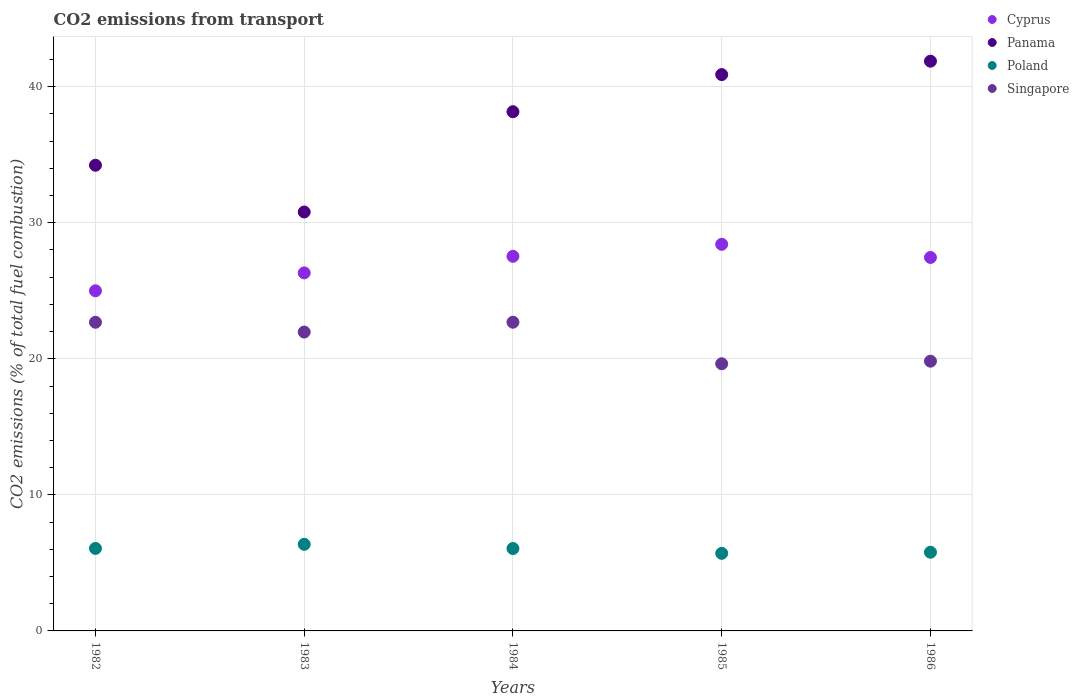Is the number of dotlines equal to the number of legend labels?
Offer a terse response. Yes. What is the total CO2 emitted in Panama in 1986?
Give a very brief answer. 41.88. Across all years, what is the maximum total CO2 emitted in Singapore?
Your response must be concise. 22.69. Across all years, what is the minimum total CO2 emitted in Cyprus?
Offer a terse response. 25. In which year was the total CO2 emitted in Poland maximum?
Keep it short and to the point. 1983. What is the total total CO2 emitted in Poland in the graph?
Make the answer very short. 29.97. What is the difference between the total CO2 emitted in Poland in 1984 and that in 1985?
Your answer should be compact. 0.36. What is the difference between the total CO2 emitted in Panama in 1985 and the total CO2 emitted in Poland in 1986?
Keep it short and to the point. 35.11. What is the average total CO2 emitted in Panama per year?
Your response must be concise. 37.19. In the year 1985, what is the difference between the total CO2 emitted in Singapore and total CO2 emitted in Poland?
Make the answer very short. 13.94. What is the ratio of the total CO2 emitted in Singapore in 1984 to that in 1985?
Your answer should be compact. 1.16. Is the difference between the total CO2 emitted in Singapore in 1983 and 1986 greater than the difference between the total CO2 emitted in Poland in 1983 and 1986?
Give a very brief answer. Yes. What is the difference between the highest and the second highest total CO2 emitted in Panama?
Make the answer very short. 0.99. What is the difference between the highest and the lowest total CO2 emitted in Panama?
Provide a short and direct response. 11.09. Is the sum of the total CO2 emitted in Singapore in 1982 and 1983 greater than the maximum total CO2 emitted in Panama across all years?
Your response must be concise. Yes. Is the total CO2 emitted in Singapore strictly less than the total CO2 emitted in Panama over the years?
Your answer should be compact. Yes. How many dotlines are there?
Ensure brevity in your answer.  4. How many years are there in the graph?
Make the answer very short. 5. Are the values on the major ticks of Y-axis written in scientific E-notation?
Your response must be concise. No. Does the graph contain any zero values?
Keep it short and to the point. No. Where does the legend appear in the graph?
Offer a very short reply. Top right. How many legend labels are there?
Your answer should be very brief. 4. What is the title of the graph?
Your answer should be compact. CO2 emissions from transport. What is the label or title of the Y-axis?
Your answer should be compact. CO2 emissions (% of total fuel combustion). What is the CO2 emissions (% of total fuel combustion) of Panama in 1982?
Offer a terse response. 34.23. What is the CO2 emissions (% of total fuel combustion) of Poland in 1982?
Your answer should be very brief. 6.06. What is the CO2 emissions (% of total fuel combustion) of Singapore in 1982?
Provide a short and direct response. 22.69. What is the CO2 emissions (% of total fuel combustion) in Cyprus in 1983?
Offer a terse response. 26.32. What is the CO2 emissions (% of total fuel combustion) of Panama in 1983?
Ensure brevity in your answer.  30.79. What is the CO2 emissions (% of total fuel combustion) of Poland in 1983?
Offer a very short reply. 6.36. What is the CO2 emissions (% of total fuel combustion) in Singapore in 1983?
Offer a terse response. 21.97. What is the CO2 emissions (% of total fuel combustion) in Cyprus in 1984?
Your response must be concise. 27.54. What is the CO2 emissions (% of total fuel combustion) in Panama in 1984?
Offer a terse response. 38.16. What is the CO2 emissions (% of total fuel combustion) of Poland in 1984?
Keep it short and to the point. 6.06. What is the CO2 emissions (% of total fuel combustion) of Singapore in 1984?
Offer a terse response. 22.69. What is the CO2 emissions (% of total fuel combustion) in Cyprus in 1985?
Your answer should be compact. 28.42. What is the CO2 emissions (% of total fuel combustion) in Panama in 1985?
Keep it short and to the point. 40.89. What is the CO2 emissions (% of total fuel combustion) of Poland in 1985?
Make the answer very short. 5.7. What is the CO2 emissions (% of total fuel combustion) in Singapore in 1985?
Offer a terse response. 19.64. What is the CO2 emissions (% of total fuel combustion) in Cyprus in 1986?
Offer a terse response. 27.45. What is the CO2 emissions (% of total fuel combustion) of Panama in 1986?
Make the answer very short. 41.88. What is the CO2 emissions (% of total fuel combustion) in Poland in 1986?
Provide a short and direct response. 5.78. What is the CO2 emissions (% of total fuel combustion) of Singapore in 1986?
Ensure brevity in your answer.  19.83. Across all years, what is the maximum CO2 emissions (% of total fuel combustion) of Cyprus?
Your response must be concise. 28.42. Across all years, what is the maximum CO2 emissions (% of total fuel combustion) of Panama?
Provide a succinct answer. 41.88. Across all years, what is the maximum CO2 emissions (% of total fuel combustion) of Poland?
Provide a succinct answer. 6.36. Across all years, what is the maximum CO2 emissions (% of total fuel combustion) of Singapore?
Offer a terse response. 22.69. Across all years, what is the minimum CO2 emissions (% of total fuel combustion) of Cyprus?
Provide a short and direct response. 25. Across all years, what is the minimum CO2 emissions (% of total fuel combustion) in Panama?
Ensure brevity in your answer.  30.79. Across all years, what is the minimum CO2 emissions (% of total fuel combustion) in Poland?
Keep it short and to the point. 5.7. Across all years, what is the minimum CO2 emissions (% of total fuel combustion) in Singapore?
Offer a very short reply. 19.64. What is the total CO2 emissions (% of total fuel combustion) in Cyprus in the graph?
Offer a very short reply. 134.72. What is the total CO2 emissions (% of total fuel combustion) in Panama in the graph?
Your answer should be very brief. 185.95. What is the total CO2 emissions (% of total fuel combustion) in Poland in the graph?
Keep it short and to the point. 29.97. What is the total CO2 emissions (% of total fuel combustion) of Singapore in the graph?
Your response must be concise. 106.81. What is the difference between the CO2 emissions (% of total fuel combustion) of Cyprus in 1982 and that in 1983?
Ensure brevity in your answer.  -1.32. What is the difference between the CO2 emissions (% of total fuel combustion) in Panama in 1982 and that in 1983?
Provide a short and direct response. 3.44. What is the difference between the CO2 emissions (% of total fuel combustion) of Poland in 1982 and that in 1983?
Offer a very short reply. -0.3. What is the difference between the CO2 emissions (% of total fuel combustion) of Singapore in 1982 and that in 1983?
Provide a short and direct response. 0.72. What is the difference between the CO2 emissions (% of total fuel combustion) of Cyprus in 1982 and that in 1984?
Provide a succinct answer. -2.54. What is the difference between the CO2 emissions (% of total fuel combustion) in Panama in 1982 and that in 1984?
Keep it short and to the point. -3.93. What is the difference between the CO2 emissions (% of total fuel combustion) of Poland in 1982 and that in 1984?
Give a very brief answer. 0.01. What is the difference between the CO2 emissions (% of total fuel combustion) in Singapore in 1982 and that in 1984?
Provide a succinct answer. -0. What is the difference between the CO2 emissions (% of total fuel combustion) in Cyprus in 1982 and that in 1985?
Offer a very short reply. -3.42. What is the difference between the CO2 emissions (% of total fuel combustion) of Panama in 1982 and that in 1985?
Your answer should be very brief. -6.66. What is the difference between the CO2 emissions (% of total fuel combustion) in Poland in 1982 and that in 1985?
Your answer should be compact. 0.36. What is the difference between the CO2 emissions (% of total fuel combustion) in Singapore in 1982 and that in 1985?
Provide a succinct answer. 3.05. What is the difference between the CO2 emissions (% of total fuel combustion) of Cyprus in 1982 and that in 1986?
Keep it short and to the point. -2.45. What is the difference between the CO2 emissions (% of total fuel combustion) of Panama in 1982 and that in 1986?
Provide a succinct answer. -7.65. What is the difference between the CO2 emissions (% of total fuel combustion) in Poland in 1982 and that in 1986?
Offer a very short reply. 0.28. What is the difference between the CO2 emissions (% of total fuel combustion) in Singapore in 1982 and that in 1986?
Offer a very short reply. 2.86. What is the difference between the CO2 emissions (% of total fuel combustion) of Cyprus in 1983 and that in 1984?
Your response must be concise. -1.22. What is the difference between the CO2 emissions (% of total fuel combustion) in Panama in 1983 and that in 1984?
Give a very brief answer. -7.37. What is the difference between the CO2 emissions (% of total fuel combustion) of Poland in 1983 and that in 1984?
Provide a short and direct response. 0.31. What is the difference between the CO2 emissions (% of total fuel combustion) of Singapore in 1983 and that in 1984?
Offer a terse response. -0.72. What is the difference between the CO2 emissions (% of total fuel combustion) in Cyprus in 1983 and that in 1985?
Your answer should be compact. -2.1. What is the difference between the CO2 emissions (% of total fuel combustion) of Panama in 1983 and that in 1985?
Offer a terse response. -10.1. What is the difference between the CO2 emissions (% of total fuel combustion) of Poland in 1983 and that in 1985?
Offer a very short reply. 0.66. What is the difference between the CO2 emissions (% of total fuel combustion) in Singapore in 1983 and that in 1985?
Your response must be concise. 2.33. What is the difference between the CO2 emissions (% of total fuel combustion) of Cyprus in 1983 and that in 1986?
Your answer should be very brief. -1.14. What is the difference between the CO2 emissions (% of total fuel combustion) in Panama in 1983 and that in 1986?
Your answer should be compact. -11.09. What is the difference between the CO2 emissions (% of total fuel combustion) of Poland in 1983 and that in 1986?
Your response must be concise. 0.58. What is the difference between the CO2 emissions (% of total fuel combustion) in Singapore in 1983 and that in 1986?
Your answer should be compact. 2.14. What is the difference between the CO2 emissions (% of total fuel combustion) of Cyprus in 1984 and that in 1985?
Give a very brief answer. -0.88. What is the difference between the CO2 emissions (% of total fuel combustion) in Panama in 1984 and that in 1985?
Offer a very short reply. -2.73. What is the difference between the CO2 emissions (% of total fuel combustion) of Poland in 1984 and that in 1985?
Ensure brevity in your answer.  0.36. What is the difference between the CO2 emissions (% of total fuel combustion) of Singapore in 1984 and that in 1985?
Keep it short and to the point. 3.05. What is the difference between the CO2 emissions (% of total fuel combustion) in Cyprus in 1984 and that in 1986?
Make the answer very short. 0.09. What is the difference between the CO2 emissions (% of total fuel combustion) in Panama in 1984 and that in 1986?
Keep it short and to the point. -3.71. What is the difference between the CO2 emissions (% of total fuel combustion) of Poland in 1984 and that in 1986?
Ensure brevity in your answer.  0.27. What is the difference between the CO2 emissions (% of total fuel combustion) in Singapore in 1984 and that in 1986?
Your answer should be compact. 2.86. What is the difference between the CO2 emissions (% of total fuel combustion) in Cyprus in 1985 and that in 1986?
Offer a very short reply. 0.97. What is the difference between the CO2 emissions (% of total fuel combustion) of Panama in 1985 and that in 1986?
Provide a succinct answer. -0.99. What is the difference between the CO2 emissions (% of total fuel combustion) of Poland in 1985 and that in 1986?
Your response must be concise. -0.08. What is the difference between the CO2 emissions (% of total fuel combustion) of Singapore in 1985 and that in 1986?
Keep it short and to the point. -0.19. What is the difference between the CO2 emissions (% of total fuel combustion) of Cyprus in 1982 and the CO2 emissions (% of total fuel combustion) of Panama in 1983?
Provide a short and direct response. -5.79. What is the difference between the CO2 emissions (% of total fuel combustion) in Cyprus in 1982 and the CO2 emissions (% of total fuel combustion) in Poland in 1983?
Give a very brief answer. 18.64. What is the difference between the CO2 emissions (% of total fuel combustion) in Cyprus in 1982 and the CO2 emissions (% of total fuel combustion) in Singapore in 1983?
Your response must be concise. 3.03. What is the difference between the CO2 emissions (% of total fuel combustion) in Panama in 1982 and the CO2 emissions (% of total fuel combustion) in Poland in 1983?
Keep it short and to the point. 27.86. What is the difference between the CO2 emissions (% of total fuel combustion) in Panama in 1982 and the CO2 emissions (% of total fuel combustion) in Singapore in 1983?
Your answer should be very brief. 12.26. What is the difference between the CO2 emissions (% of total fuel combustion) in Poland in 1982 and the CO2 emissions (% of total fuel combustion) in Singapore in 1983?
Provide a short and direct response. -15.9. What is the difference between the CO2 emissions (% of total fuel combustion) of Cyprus in 1982 and the CO2 emissions (% of total fuel combustion) of Panama in 1984?
Your answer should be very brief. -13.16. What is the difference between the CO2 emissions (% of total fuel combustion) of Cyprus in 1982 and the CO2 emissions (% of total fuel combustion) of Poland in 1984?
Your response must be concise. 18.94. What is the difference between the CO2 emissions (% of total fuel combustion) in Cyprus in 1982 and the CO2 emissions (% of total fuel combustion) in Singapore in 1984?
Provide a succinct answer. 2.31. What is the difference between the CO2 emissions (% of total fuel combustion) of Panama in 1982 and the CO2 emissions (% of total fuel combustion) of Poland in 1984?
Give a very brief answer. 28.17. What is the difference between the CO2 emissions (% of total fuel combustion) in Panama in 1982 and the CO2 emissions (% of total fuel combustion) in Singapore in 1984?
Offer a very short reply. 11.54. What is the difference between the CO2 emissions (% of total fuel combustion) of Poland in 1982 and the CO2 emissions (% of total fuel combustion) of Singapore in 1984?
Your answer should be compact. -16.63. What is the difference between the CO2 emissions (% of total fuel combustion) of Cyprus in 1982 and the CO2 emissions (% of total fuel combustion) of Panama in 1985?
Make the answer very short. -15.89. What is the difference between the CO2 emissions (% of total fuel combustion) in Cyprus in 1982 and the CO2 emissions (% of total fuel combustion) in Poland in 1985?
Provide a succinct answer. 19.3. What is the difference between the CO2 emissions (% of total fuel combustion) of Cyprus in 1982 and the CO2 emissions (% of total fuel combustion) of Singapore in 1985?
Ensure brevity in your answer.  5.36. What is the difference between the CO2 emissions (% of total fuel combustion) of Panama in 1982 and the CO2 emissions (% of total fuel combustion) of Poland in 1985?
Offer a terse response. 28.53. What is the difference between the CO2 emissions (% of total fuel combustion) in Panama in 1982 and the CO2 emissions (% of total fuel combustion) in Singapore in 1985?
Ensure brevity in your answer.  14.59. What is the difference between the CO2 emissions (% of total fuel combustion) of Poland in 1982 and the CO2 emissions (% of total fuel combustion) of Singapore in 1985?
Your answer should be very brief. -13.57. What is the difference between the CO2 emissions (% of total fuel combustion) in Cyprus in 1982 and the CO2 emissions (% of total fuel combustion) in Panama in 1986?
Give a very brief answer. -16.88. What is the difference between the CO2 emissions (% of total fuel combustion) of Cyprus in 1982 and the CO2 emissions (% of total fuel combustion) of Poland in 1986?
Provide a short and direct response. 19.22. What is the difference between the CO2 emissions (% of total fuel combustion) in Cyprus in 1982 and the CO2 emissions (% of total fuel combustion) in Singapore in 1986?
Ensure brevity in your answer.  5.17. What is the difference between the CO2 emissions (% of total fuel combustion) of Panama in 1982 and the CO2 emissions (% of total fuel combustion) of Poland in 1986?
Give a very brief answer. 28.44. What is the difference between the CO2 emissions (% of total fuel combustion) in Panama in 1982 and the CO2 emissions (% of total fuel combustion) in Singapore in 1986?
Make the answer very short. 14.4. What is the difference between the CO2 emissions (% of total fuel combustion) in Poland in 1982 and the CO2 emissions (% of total fuel combustion) in Singapore in 1986?
Provide a succinct answer. -13.76. What is the difference between the CO2 emissions (% of total fuel combustion) of Cyprus in 1983 and the CO2 emissions (% of total fuel combustion) of Panama in 1984?
Ensure brevity in your answer.  -11.85. What is the difference between the CO2 emissions (% of total fuel combustion) in Cyprus in 1983 and the CO2 emissions (% of total fuel combustion) in Poland in 1984?
Provide a succinct answer. 20.26. What is the difference between the CO2 emissions (% of total fuel combustion) in Cyprus in 1983 and the CO2 emissions (% of total fuel combustion) in Singapore in 1984?
Provide a short and direct response. 3.63. What is the difference between the CO2 emissions (% of total fuel combustion) of Panama in 1983 and the CO2 emissions (% of total fuel combustion) of Poland in 1984?
Provide a short and direct response. 24.73. What is the difference between the CO2 emissions (% of total fuel combustion) in Panama in 1983 and the CO2 emissions (% of total fuel combustion) in Singapore in 1984?
Make the answer very short. 8.1. What is the difference between the CO2 emissions (% of total fuel combustion) in Poland in 1983 and the CO2 emissions (% of total fuel combustion) in Singapore in 1984?
Offer a very short reply. -16.33. What is the difference between the CO2 emissions (% of total fuel combustion) in Cyprus in 1983 and the CO2 emissions (% of total fuel combustion) in Panama in 1985?
Make the answer very short. -14.58. What is the difference between the CO2 emissions (% of total fuel combustion) in Cyprus in 1983 and the CO2 emissions (% of total fuel combustion) in Poland in 1985?
Offer a terse response. 20.61. What is the difference between the CO2 emissions (% of total fuel combustion) in Cyprus in 1983 and the CO2 emissions (% of total fuel combustion) in Singapore in 1985?
Make the answer very short. 6.68. What is the difference between the CO2 emissions (% of total fuel combustion) of Panama in 1983 and the CO2 emissions (% of total fuel combustion) of Poland in 1985?
Provide a succinct answer. 25.09. What is the difference between the CO2 emissions (% of total fuel combustion) in Panama in 1983 and the CO2 emissions (% of total fuel combustion) in Singapore in 1985?
Your response must be concise. 11.15. What is the difference between the CO2 emissions (% of total fuel combustion) in Poland in 1983 and the CO2 emissions (% of total fuel combustion) in Singapore in 1985?
Give a very brief answer. -13.27. What is the difference between the CO2 emissions (% of total fuel combustion) in Cyprus in 1983 and the CO2 emissions (% of total fuel combustion) in Panama in 1986?
Give a very brief answer. -15.56. What is the difference between the CO2 emissions (% of total fuel combustion) of Cyprus in 1983 and the CO2 emissions (% of total fuel combustion) of Poland in 1986?
Ensure brevity in your answer.  20.53. What is the difference between the CO2 emissions (% of total fuel combustion) of Cyprus in 1983 and the CO2 emissions (% of total fuel combustion) of Singapore in 1986?
Offer a terse response. 6.49. What is the difference between the CO2 emissions (% of total fuel combustion) of Panama in 1983 and the CO2 emissions (% of total fuel combustion) of Poland in 1986?
Your answer should be very brief. 25.01. What is the difference between the CO2 emissions (% of total fuel combustion) of Panama in 1983 and the CO2 emissions (% of total fuel combustion) of Singapore in 1986?
Your answer should be compact. 10.96. What is the difference between the CO2 emissions (% of total fuel combustion) of Poland in 1983 and the CO2 emissions (% of total fuel combustion) of Singapore in 1986?
Your answer should be compact. -13.46. What is the difference between the CO2 emissions (% of total fuel combustion) of Cyprus in 1984 and the CO2 emissions (% of total fuel combustion) of Panama in 1985?
Offer a terse response. -13.36. What is the difference between the CO2 emissions (% of total fuel combustion) in Cyprus in 1984 and the CO2 emissions (% of total fuel combustion) in Poland in 1985?
Keep it short and to the point. 21.83. What is the difference between the CO2 emissions (% of total fuel combustion) in Cyprus in 1984 and the CO2 emissions (% of total fuel combustion) in Singapore in 1985?
Give a very brief answer. 7.9. What is the difference between the CO2 emissions (% of total fuel combustion) of Panama in 1984 and the CO2 emissions (% of total fuel combustion) of Poland in 1985?
Ensure brevity in your answer.  32.46. What is the difference between the CO2 emissions (% of total fuel combustion) of Panama in 1984 and the CO2 emissions (% of total fuel combustion) of Singapore in 1985?
Provide a succinct answer. 18.52. What is the difference between the CO2 emissions (% of total fuel combustion) in Poland in 1984 and the CO2 emissions (% of total fuel combustion) in Singapore in 1985?
Make the answer very short. -13.58. What is the difference between the CO2 emissions (% of total fuel combustion) of Cyprus in 1984 and the CO2 emissions (% of total fuel combustion) of Panama in 1986?
Provide a short and direct response. -14.34. What is the difference between the CO2 emissions (% of total fuel combustion) in Cyprus in 1984 and the CO2 emissions (% of total fuel combustion) in Poland in 1986?
Give a very brief answer. 21.75. What is the difference between the CO2 emissions (% of total fuel combustion) in Cyprus in 1984 and the CO2 emissions (% of total fuel combustion) in Singapore in 1986?
Provide a succinct answer. 7.71. What is the difference between the CO2 emissions (% of total fuel combustion) in Panama in 1984 and the CO2 emissions (% of total fuel combustion) in Poland in 1986?
Make the answer very short. 32.38. What is the difference between the CO2 emissions (% of total fuel combustion) of Panama in 1984 and the CO2 emissions (% of total fuel combustion) of Singapore in 1986?
Your response must be concise. 18.34. What is the difference between the CO2 emissions (% of total fuel combustion) of Poland in 1984 and the CO2 emissions (% of total fuel combustion) of Singapore in 1986?
Your answer should be compact. -13.77. What is the difference between the CO2 emissions (% of total fuel combustion) in Cyprus in 1985 and the CO2 emissions (% of total fuel combustion) in Panama in 1986?
Provide a succinct answer. -13.46. What is the difference between the CO2 emissions (% of total fuel combustion) in Cyprus in 1985 and the CO2 emissions (% of total fuel combustion) in Poland in 1986?
Your answer should be compact. 22.63. What is the difference between the CO2 emissions (% of total fuel combustion) of Cyprus in 1985 and the CO2 emissions (% of total fuel combustion) of Singapore in 1986?
Your response must be concise. 8.59. What is the difference between the CO2 emissions (% of total fuel combustion) of Panama in 1985 and the CO2 emissions (% of total fuel combustion) of Poland in 1986?
Provide a succinct answer. 35.11. What is the difference between the CO2 emissions (% of total fuel combustion) of Panama in 1985 and the CO2 emissions (% of total fuel combustion) of Singapore in 1986?
Give a very brief answer. 21.07. What is the difference between the CO2 emissions (% of total fuel combustion) in Poland in 1985 and the CO2 emissions (% of total fuel combustion) in Singapore in 1986?
Provide a short and direct response. -14.12. What is the average CO2 emissions (% of total fuel combustion) of Cyprus per year?
Keep it short and to the point. 26.94. What is the average CO2 emissions (% of total fuel combustion) of Panama per year?
Offer a terse response. 37.19. What is the average CO2 emissions (% of total fuel combustion) in Poland per year?
Your response must be concise. 5.99. What is the average CO2 emissions (% of total fuel combustion) of Singapore per year?
Provide a succinct answer. 21.36. In the year 1982, what is the difference between the CO2 emissions (% of total fuel combustion) of Cyprus and CO2 emissions (% of total fuel combustion) of Panama?
Give a very brief answer. -9.23. In the year 1982, what is the difference between the CO2 emissions (% of total fuel combustion) of Cyprus and CO2 emissions (% of total fuel combustion) of Poland?
Make the answer very short. 18.94. In the year 1982, what is the difference between the CO2 emissions (% of total fuel combustion) in Cyprus and CO2 emissions (% of total fuel combustion) in Singapore?
Ensure brevity in your answer.  2.31. In the year 1982, what is the difference between the CO2 emissions (% of total fuel combustion) in Panama and CO2 emissions (% of total fuel combustion) in Poland?
Offer a terse response. 28.16. In the year 1982, what is the difference between the CO2 emissions (% of total fuel combustion) in Panama and CO2 emissions (% of total fuel combustion) in Singapore?
Provide a short and direct response. 11.54. In the year 1982, what is the difference between the CO2 emissions (% of total fuel combustion) in Poland and CO2 emissions (% of total fuel combustion) in Singapore?
Offer a terse response. -16.62. In the year 1983, what is the difference between the CO2 emissions (% of total fuel combustion) in Cyprus and CO2 emissions (% of total fuel combustion) in Panama?
Give a very brief answer. -4.48. In the year 1983, what is the difference between the CO2 emissions (% of total fuel combustion) of Cyprus and CO2 emissions (% of total fuel combustion) of Poland?
Give a very brief answer. 19.95. In the year 1983, what is the difference between the CO2 emissions (% of total fuel combustion) in Cyprus and CO2 emissions (% of total fuel combustion) in Singapore?
Give a very brief answer. 4.35. In the year 1983, what is the difference between the CO2 emissions (% of total fuel combustion) of Panama and CO2 emissions (% of total fuel combustion) of Poland?
Provide a succinct answer. 24.43. In the year 1983, what is the difference between the CO2 emissions (% of total fuel combustion) in Panama and CO2 emissions (% of total fuel combustion) in Singapore?
Make the answer very short. 8.82. In the year 1983, what is the difference between the CO2 emissions (% of total fuel combustion) in Poland and CO2 emissions (% of total fuel combustion) in Singapore?
Provide a short and direct response. -15.6. In the year 1984, what is the difference between the CO2 emissions (% of total fuel combustion) of Cyprus and CO2 emissions (% of total fuel combustion) of Panama?
Ensure brevity in your answer.  -10.63. In the year 1984, what is the difference between the CO2 emissions (% of total fuel combustion) in Cyprus and CO2 emissions (% of total fuel combustion) in Poland?
Your response must be concise. 21.48. In the year 1984, what is the difference between the CO2 emissions (% of total fuel combustion) of Cyprus and CO2 emissions (% of total fuel combustion) of Singapore?
Your response must be concise. 4.85. In the year 1984, what is the difference between the CO2 emissions (% of total fuel combustion) in Panama and CO2 emissions (% of total fuel combustion) in Poland?
Ensure brevity in your answer.  32.11. In the year 1984, what is the difference between the CO2 emissions (% of total fuel combustion) of Panama and CO2 emissions (% of total fuel combustion) of Singapore?
Give a very brief answer. 15.47. In the year 1984, what is the difference between the CO2 emissions (% of total fuel combustion) of Poland and CO2 emissions (% of total fuel combustion) of Singapore?
Make the answer very short. -16.63. In the year 1985, what is the difference between the CO2 emissions (% of total fuel combustion) in Cyprus and CO2 emissions (% of total fuel combustion) in Panama?
Your answer should be compact. -12.47. In the year 1985, what is the difference between the CO2 emissions (% of total fuel combustion) of Cyprus and CO2 emissions (% of total fuel combustion) of Poland?
Offer a terse response. 22.72. In the year 1985, what is the difference between the CO2 emissions (% of total fuel combustion) of Cyprus and CO2 emissions (% of total fuel combustion) of Singapore?
Provide a short and direct response. 8.78. In the year 1985, what is the difference between the CO2 emissions (% of total fuel combustion) of Panama and CO2 emissions (% of total fuel combustion) of Poland?
Offer a terse response. 35.19. In the year 1985, what is the difference between the CO2 emissions (% of total fuel combustion) in Panama and CO2 emissions (% of total fuel combustion) in Singapore?
Provide a short and direct response. 21.25. In the year 1985, what is the difference between the CO2 emissions (% of total fuel combustion) in Poland and CO2 emissions (% of total fuel combustion) in Singapore?
Your answer should be very brief. -13.94. In the year 1986, what is the difference between the CO2 emissions (% of total fuel combustion) in Cyprus and CO2 emissions (% of total fuel combustion) in Panama?
Give a very brief answer. -14.43. In the year 1986, what is the difference between the CO2 emissions (% of total fuel combustion) in Cyprus and CO2 emissions (% of total fuel combustion) in Poland?
Offer a very short reply. 21.67. In the year 1986, what is the difference between the CO2 emissions (% of total fuel combustion) in Cyprus and CO2 emissions (% of total fuel combustion) in Singapore?
Give a very brief answer. 7.62. In the year 1986, what is the difference between the CO2 emissions (% of total fuel combustion) of Panama and CO2 emissions (% of total fuel combustion) of Poland?
Keep it short and to the point. 36.09. In the year 1986, what is the difference between the CO2 emissions (% of total fuel combustion) of Panama and CO2 emissions (% of total fuel combustion) of Singapore?
Your answer should be very brief. 22.05. In the year 1986, what is the difference between the CO2 emissions (% of total fuel combustion) in Poland and CO2 emissions (% of total fuel combustion) in Singapore?
Make the answer very short. -14.04. What is the ratio of the CO2 emissions (% of total fuel combustion) of Cyprus in 1982 to that in 1983?
Your answer should be compact. 0.95. What is the ratio of the CO2 emissions (% of total fuel combustion) in Panama in 1982 to that in 1983?
Offer a terse response. 1.11. What is the ratio of the CO2 emissions (% of total fuel combustion) in Poland in 1982 to that in 1983?
Make the answer very short. 0.95. What is the ratio of the CO2 emissions (% of total fuel combustion) in Singapore in 1982 to that in 1983?
Give a very brief answer. 1.03. What is the ratio of the CO2 emissions (% of total fuel combustion) in Cyprus in 1982 to that in 1984?
Your response must be concise. 0.91. What is the ratio of the CO2 emissions (% of total fuel combustion) in Panama in 1982 to that in 1984?
Provide a short and direct response. 0.9. What is the ratio of the CO2 emissions (% of total fuel combustion) in Cyprus in 1982 to that in 1985?
Provide a succinct answer. 0.88. What is the ratio of the CO2 emissions (% of total fuel combustion) in Panama in 1982 to that in 1985?
Provide a short and direct response. 0.84. What is the ratio of the CO2 emissions (% of total fuel combustion) in Poland in 1982 to that in 1985?
Provide a succinct answer. 1.06. What is the ratio of the CO2 emissions (% of total fuel combustion) of Singapore in 1982 to that in 1985?
Your answer should be compact. 1.16. What is the ratio of the CO2 emissions (% of total fuel combustion) of Cyprus in 1982 to that in 1986?
Provide a succinct answer. 0.91. What is the ratio of the CO2 emissions (% of total fuel combustion) in Panama in 1982 to that in 1986?
Offer a very short reply. 0.82. What is the ratio of the CO2 emissions (% of total fuel combustion) in Poland in 1982 to that in 1986?
Make the answer very short. 1.05. What is the ratio of the CO2 emissions (% of total fuel combustion) in Singapore in 1982 to that in 1986?
Provide a short and direct response. 1.14. What is the ratio of the CO2 emissions (% of total fuel combustion) of Cyprus in 1983 to that in 1984?
Provide a short and direct response. 0.96. What is the ratio of the CO2 emissions (% of total fuel combustion) of Panama in 1983 to that in 1984?
Provide a short and direct response. 0.81. What is the ratio of the CO2 emissions (% of total fuel combustion) of Poland in 1983 to that in 1984?
Ensure brevity in your answer.  1.05. What is the ratio of the CO2 emissions (% of total fuel combustion) of Singapore in 1983 to that in 1984?
Make the answer very short. 0.97. What is the ratio of the CO2 emissions (% of total fuel combustion) in Cyprus in 1983 to that in 1985?
Ensure brevity in your answer.  0.93. What is the ratio of the CO2 emissions (% of total fuel combustion) in Panama in 1983 to that in 1985?
Make the answer very short. 0.75. What is the ratio of the CO2 emissions (% of total fuel combustion) of Poland in 1983 to that in 1985?
Provide a short and direct response. 1.12. What is the ratio of the CO2 emissions (% of total fuel combustion) in Singapore in 1983 to that in 1985?
Ensure brevity in your answer.  1.12. What is the ratio of the CO2 emissions (% of total fuel combustion) of Cyprus in 1983 to that in 1986?
Your response must be concise. 0.96. What is the ratio of the CO2 emissions (% of total fuel combustion) of Panama in 1983 to that in 1986?
Provide a short and direct response. 0.74. What is the ratio of the CO2 emissions (% of total fuel combustion) of Poland in 1983 to that in 1986?
Keep it short and to the point. 1.1. What is the ratio of the CO2 emissions (% of total fuel combustion) of Singapore in 1983 to that in 1986?
Ensure brevity in your answer.  1.11. What is the ratio of the CO2 emissions (% of total fuel combustion) of Panama in 1984 to that in 1985?
Your answer should be very brief. 0.93. What is the ratio of the CO2 emissions (% of total fuel combustion) of Poland in 1984 to that in 1985?
Ensure brevity in your answer.  1.06. What is the ratio of the CO2 emissions (% of total fuel combustion) of Singapore in 1984 to that in 1985?
Provide a short and direct response. 1.16. What is the ratio of the CO2 emissions (% of total fuel combustion) in Panama in 1984 to that in 1986?
Your answer should be very brief. 0.91. What is the ratio of the CO2 emissions (% of total fuel combustion) of Poland in 1984 to that in 1986?
Provide a short and direct response. 1.05. What is the ratio of the CO2 emissions (% of total fuel combustion) of Singapore in 1984 to that in 1986?
Offer a terse response. 1.14. What is the ratio of the CO2 emissions (% of total fuel combustion) in Cyprus in 1985 to that in 1986?
Your answer should be very brief. 1.04. What is the ratio of the CO2 emissions (% of total fuel combustion) in Panama in 1985 to that in 1986?
Offer a very short reply. 0.98. What is the ratio of the CO2 emissions (% of total fuel combustion) of Poland in 1985 to that in 1986?
Provide a short and direct response. 0.99. What is the ratio of the CO2 emissions (% of total fuel combustion) in Singapore in 1985 to that in 1986?
Offer a very short reply. 0.99. What is the difference between the highest and the second highest CO2 emissions (% of total fuel combustion) of Cyprus?
Offer a very short reply. 0.88. What is the difference between the highest and the second highest CO2 emissions (% of total fuel combustion) of Panama?
Keep it short and to the point. 0.99. What is the difference between the highest and the second highest CO2 emissions (% of total fuel combustion) in Poland?
Your answer should be very brief. 0.3. What is the difference between the highest and the second highest CO2 emissions (% of total fuel combustion) of Singapore?
Your response must be concise. 0. What is the difference between the highest and the lowest CO2 emissions (% of total fuel combustion) in Cyprus?
Make the answer very short. 3.42. What is the difference between the highest and the lowest CO2 emissions (% of total fuel combustion) of Panama?
Offer a terse response. 11.09. What is the difference between the highest and the lowest CO2 emissions (% of total fuel combustion) of Poland?
Provide a succinct answer. 0.66. What is the difference between the highest and the lowest CO2 emissions (% of total fuel combustion) in Singapore?
Keep it short and to the point. 3.05. 